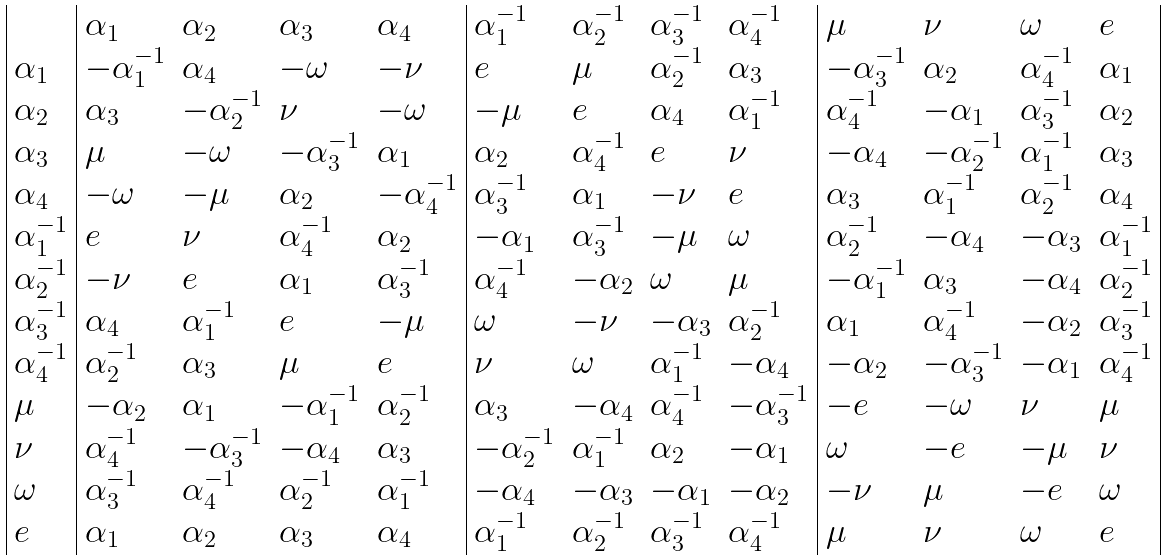Convert formula to latex. <formula><loc_0><loc_0><loc_500><loc_500>\begin{array} { | l | l l l l | l l l l | l l l l | } & \alpha _ { 1 } & \alpha _ { 2 } & \alpha _ { 3 } & \alpha _ { 4 } & \alpha _ { 1 } ^ { - 1 } & \alpha _ { 2 } ^ { - 1 } & \alpha _ { 3 } ^ { - 1 } & \alpha _ { 4 } ^ { - 1 } & \mu & \nu & \omega & e \\ \alpha _ { 1 } & - \alpha _ { 1 } ^ { - 1 } & \alpha _ { 4 } & - \omega & - \nu & e & \mu & \alpha _ { 2 } ^ { - 1 } & \alpha _ { 3 } & - \alpha _ { 3 } ^ { - 1 } & \alpha _ { 2 } & \alpha _ { 4 } ^ { - 1 } & \alpha _ { 1 } \\ \alpha _ { 2 } & \alpha _ { 3 } & - \alpha _ { 2 } ^ { - 1 } & \nu & - \omega & - \mu & e & \alpha _ { 4 } & \alpha _ { 1 } ^ { - 1 } & \alpha _ { 4 } ^ { - 1 } & - \alpha _ { 1 } & \alpha _ { 3 } ^ { - 1 } & \alpha _ { 2 } \\ \alpha _ { 3 } & \mu & - \omega & - \alpha _ { 3 } ^ { - 1 } & \alpha _ { 1 } & \alpha _ { 2 } & \alpha _ { 4 } ^ { - 1 } & e & \nu & - \alpha _ { 4 } & - \alpha _ { 2 } ^ { - 1 } & \alpha _ { 1 } ^ { - 1 } & \alpha _ { 3 } \\ \alpha _ { 4 } & - \omega & - \mu & \alpha _ { 2 } & - \alpha _ { 4 } ^ { - 1 } & \alpha _ { 3 } ^ { - 1 } & \alpha _ { 1 } & - \nu & e & \alpha _ { 3 } & \alpha _ { 1 } ^ { - 1 } & \alpha _ { 2 } ^ { - 1 } & \alpha _ { 4 } \\ \alpha _ { 1 } ^ { - 1 } & e & \nu & \alpha _ { 4 } ^ { - 1 } & \alpha _ { 2 } & - \alpha _ { 1 } & \alpha _ { 3 } ^ { - 1 } & - \mu & \omega & \alpha _ { 2 } ^ { - 1 } & - \alpha _ { 4 } & - \alpha _ { 3 } & \alpha _ { 1 } ^ { - 1 } \\ \alpha _ { 2 } ^ { - 1 } & - \nu & e & \alpha _ { 1 } & \alpha _ { 3 } ^ { - 1 } & \alpha _ { 4 } ^ { - 1 } & - \alpha _ { 2 } & \omega & \mu & - \alpha _ { 1 } ^ { - 1 } & \alpha _ { 3 } & - \alpha _ { 4 } & \alpha _ { 2 } ^ { - 1 } \\ \alpha _ { 3 } ^ { - 1 } & \alpha _ { 4 } & \alpha _ { 1 } ^ { - 1 } & e & - \mu & \omega & - \nu & - \alpha _ { 3 } & \alpha _ { 2 } ^ { - 1 } & \alpha _ { 1 } & \alpha _ { 4 } ^ { - 1 } & - \alpha _ { 2 } & \alpha _ { 3 } ^ { - 1 } \\ \alpha _ { 4 } ^ { - 1 } & \alpha _ { 2 } ^ { - 1 } & \alpha _ { 3 } & \mu & e & \nu & \omega & \alpha _ { 1 } ^ { - 1 } & - \alpha _ { 4 } & - \alpha _ { 2 } & - \alpha _ { 3 } ^ { - 1 } & - \alpha _ { 1 } & \alpha _ { 4 } ^ { - 1 } \\ \mu & - \alpha _ { 2 } & \alpha _ { 1 } & - \alpha _ { 1 } ^ { - 1 } & \alpha _ { 2 } ^ { - 1 } & \alpha _ { 3 } & - \alpha _ { 4 } & \alpha _ { 4 } ^ { - 1 } & - \alpha _ { 3 } ^ { - 1 } & - e & - \omega & \nu & \mu \\ \nu & \alpha _ { 4 } ^ { - 1 } & - \alpha _ { 3 } ^ { - 1 } & - \alpha _ { 4 } & \alpha _ { 3 } & - \alpha _ { 2 } ^ { - 1 } & \alpha _ { 1 } ^ { - 1 } & \alpha _ { 2 } & - \alpha _ { 1 } & \omega & - e & - \mu & \nu \\ \omega & \alpha _ { 3 } ^ { - 1 } & \alpha _ { 4 } ^ { - 1 } & \alpha _ { 2 } ^ { - 1 } & \alpha _ { 1 } ^ { - 1 } & - \alpha _ { 4 } & - \alpha _ { 3 } & - \alpha _ { 1 } & - \alpha _ { 2 } & - \nu & \mu & - e & \omega \\ e & \alpha _ { 1 } & \alpha _ { 2 } & \alpha _ { 3 } & \alpha _ { 4 } & \alpha _ { 1 } ^ { - 1 } & \alpha _ { 2 } ^ { - 1 } & \alpha _ { 3 } ^ { - 1 } & \alpha _ { 4 } ^ { - 1 } & \mu & \nu & \omega & e \\ \end{array}</formula> 